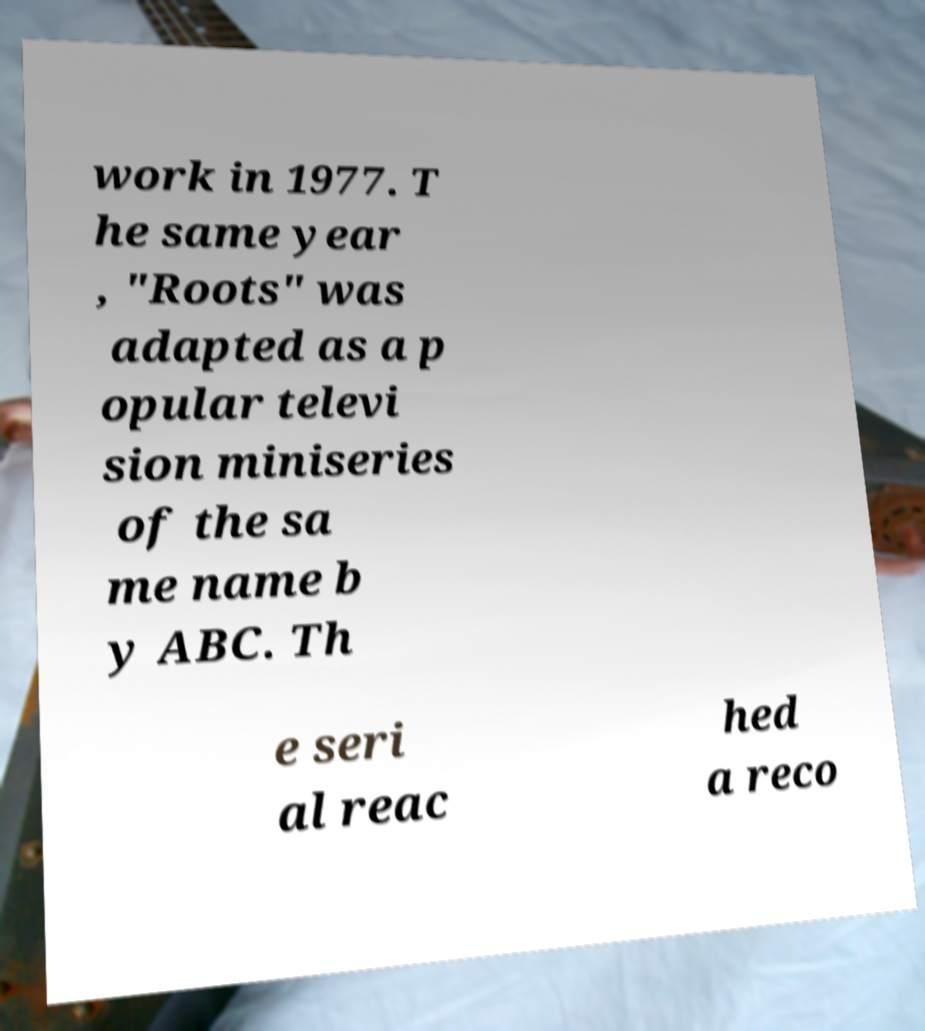Can you read and provide the text displayed in the image?This photo seems to have some interesting text. Can you extract and type it out for me? work in 1977. T he same year , "Roots" was adapted as a p opular televi sion miniseries of the sa me name b y ABC. Th e seri al reac hed a reco 